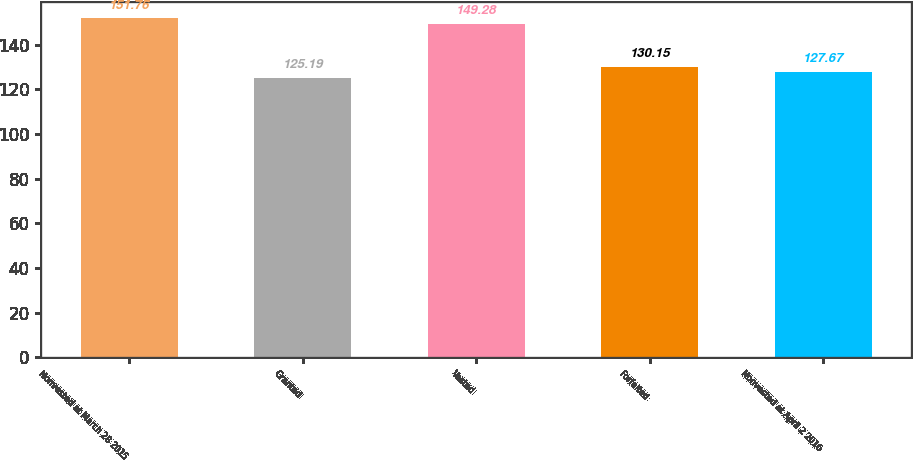Convert chart to OTSL. <chart><loc_0><loc_0><loc_500><loc_500><bar_chart><fcel>Nonvested at March 28 2015<fcel>Granted<fcel>Vested<fcel>Forfeited<fcel>Nonvested at April 2 2016<nl><fcel>151.76<fcel>125.19<fcel>149.28<fcel>130.15<fcel>127.67<nl></chart> 